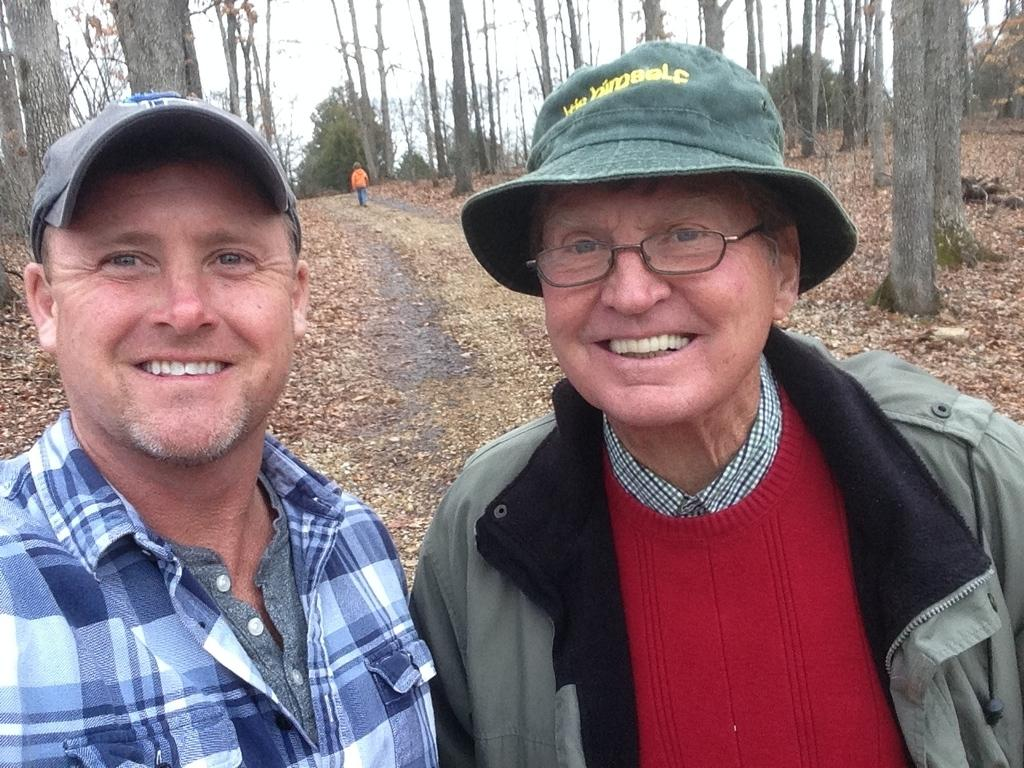How many men are in the foreground of the image? There are two men in the foreground of the image. What are the men wearing on their heads? The men are wearing hats. What expressions do the men have on their faces? The men have smiles on their faces. What can be seen in the background of the image? There are trees and the sky visible in the background of the image. Is there any activity happening in the background of the image? Yes, there is a boy walking on a path in the background of the image. What type of attack is being launched by the quartz in the image? There is no quartz present in the image, and therefore no such attack can be observed. 